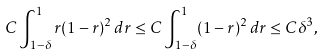Convert formula to latex. <formula><loc_0><loc_0><loc_500><loc_500>C \int _ { 1 - \delta } ^ { 1 } r ( 1 - r ) ^ { 2 } \, d r \leq C \int _ { 1 - \delta } ^ { 1 } ( 1 - r ) ^ { 2 } \, d r \leq C \delta ^ { 3 } ,</formula> 